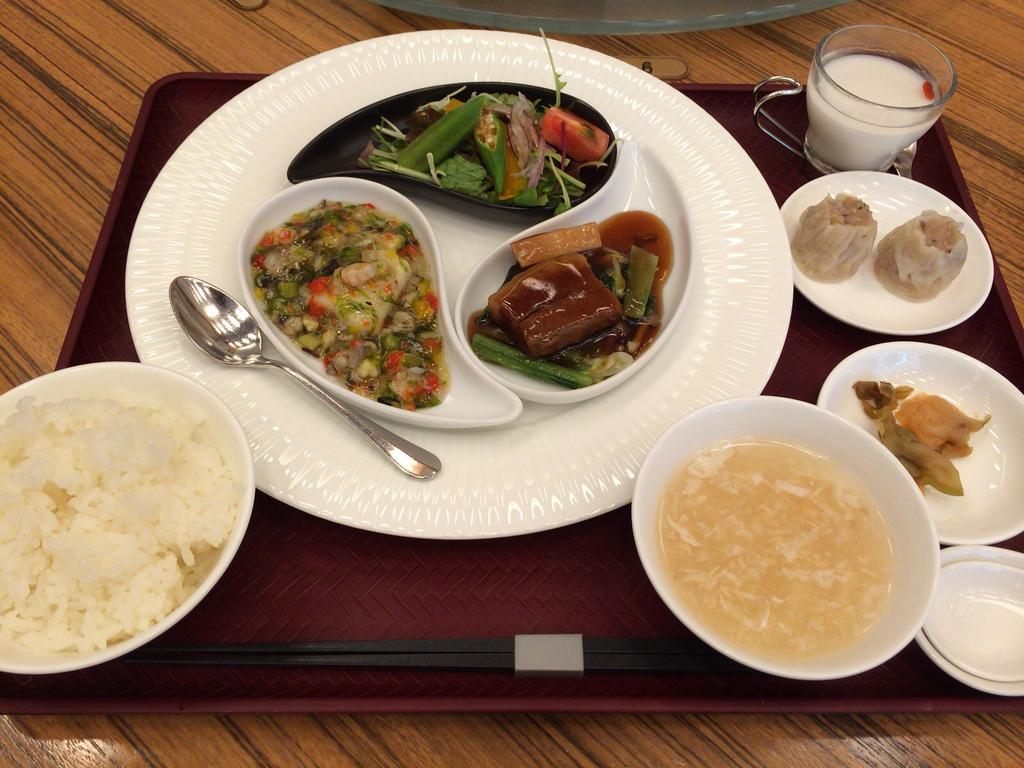In one or two sentences, can you explain what this image depicts? In this image we can see food items in bowls and plates. There is a cup with some liquid. There is a spoon on the table. 